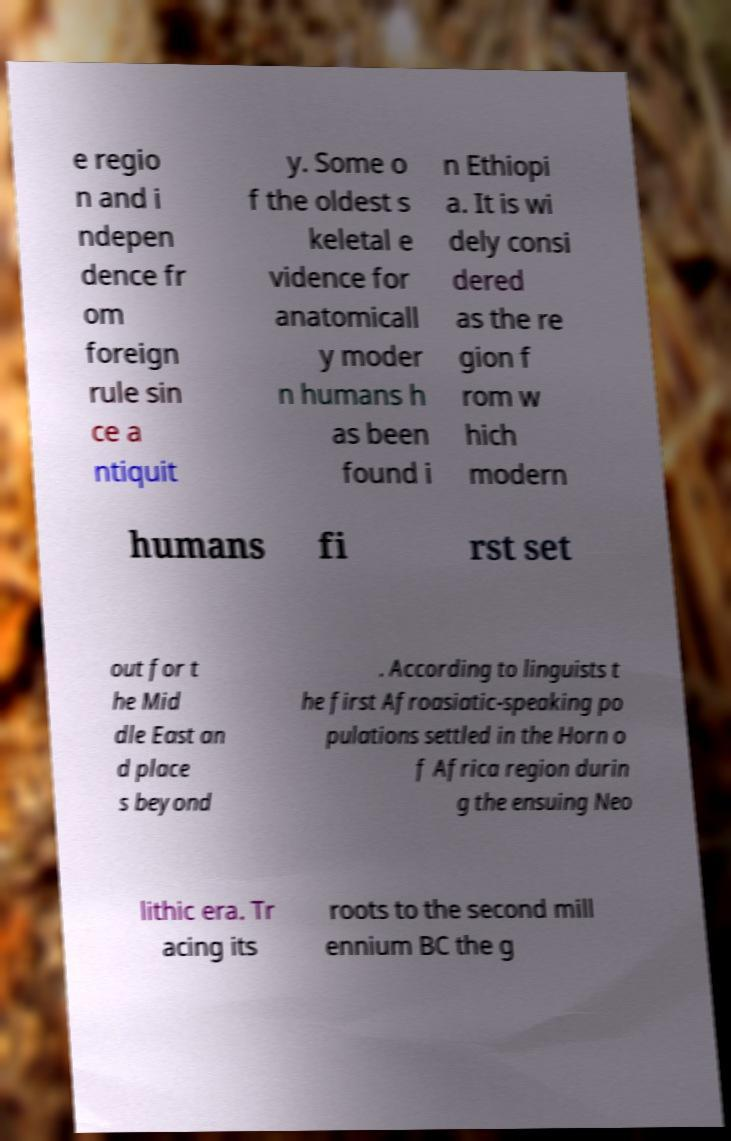Please read and relay the text visible in this image. What does it say? e regio n and i ndepen dence fr om foreign rule sin ce a ntiquit y. Some o f the oldest s keletal e vidence for anatomicall y moder n humans h as been found i n Ethiopi a. It is wi dely consi dered as the re gion f rom w hich modern humans fi rst set out for t he Mid dle East an d place s beyond . According to linguists t he first Afroasiatic-speaking po pulations settled in the Horn o f Africa region durin g the ensuing Neo lithic era. Tr acing its roots to the second mill ennium BC the g 